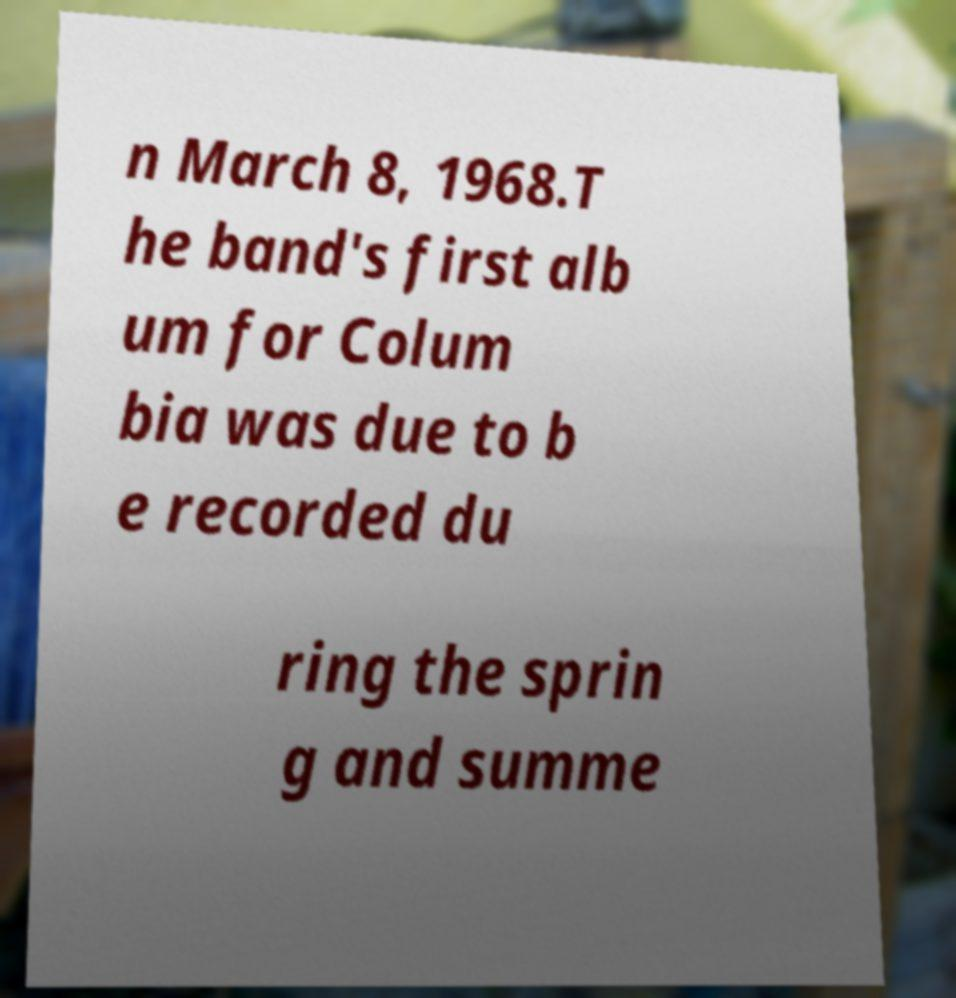I need the written content from this picture converted into text. Can you do that? n March 8, 1968.T he band's first alb um for Colum bia was due to b e recorded du ring the sprin g and summe 